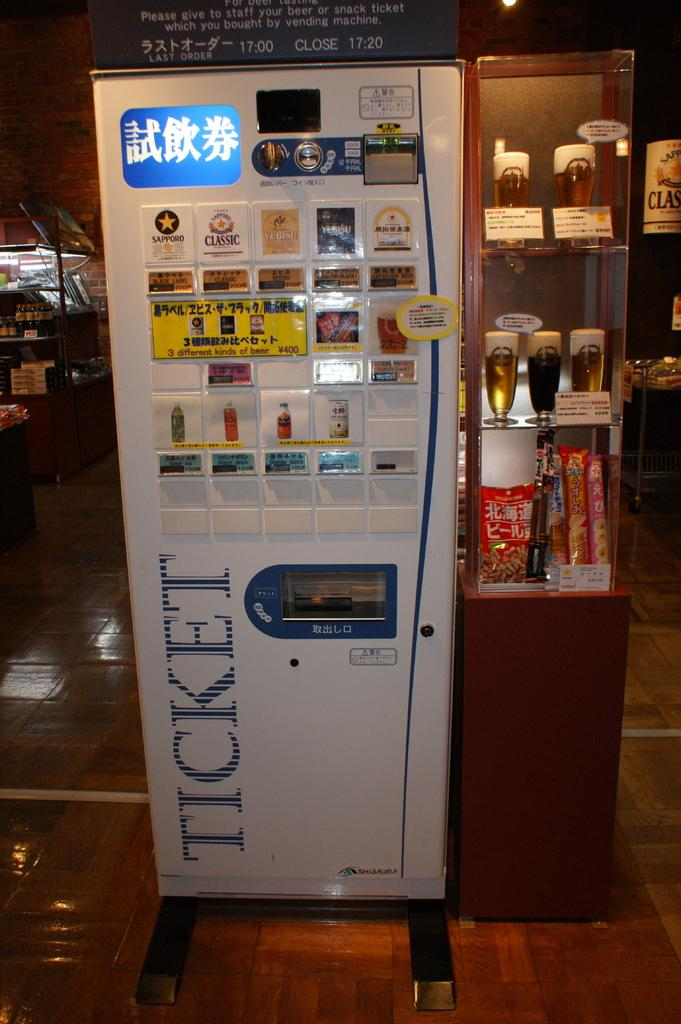Provide a one-sentence caption for the provided image. A ticketing machine selling a ticket for Sapporo beer among other drinks. 